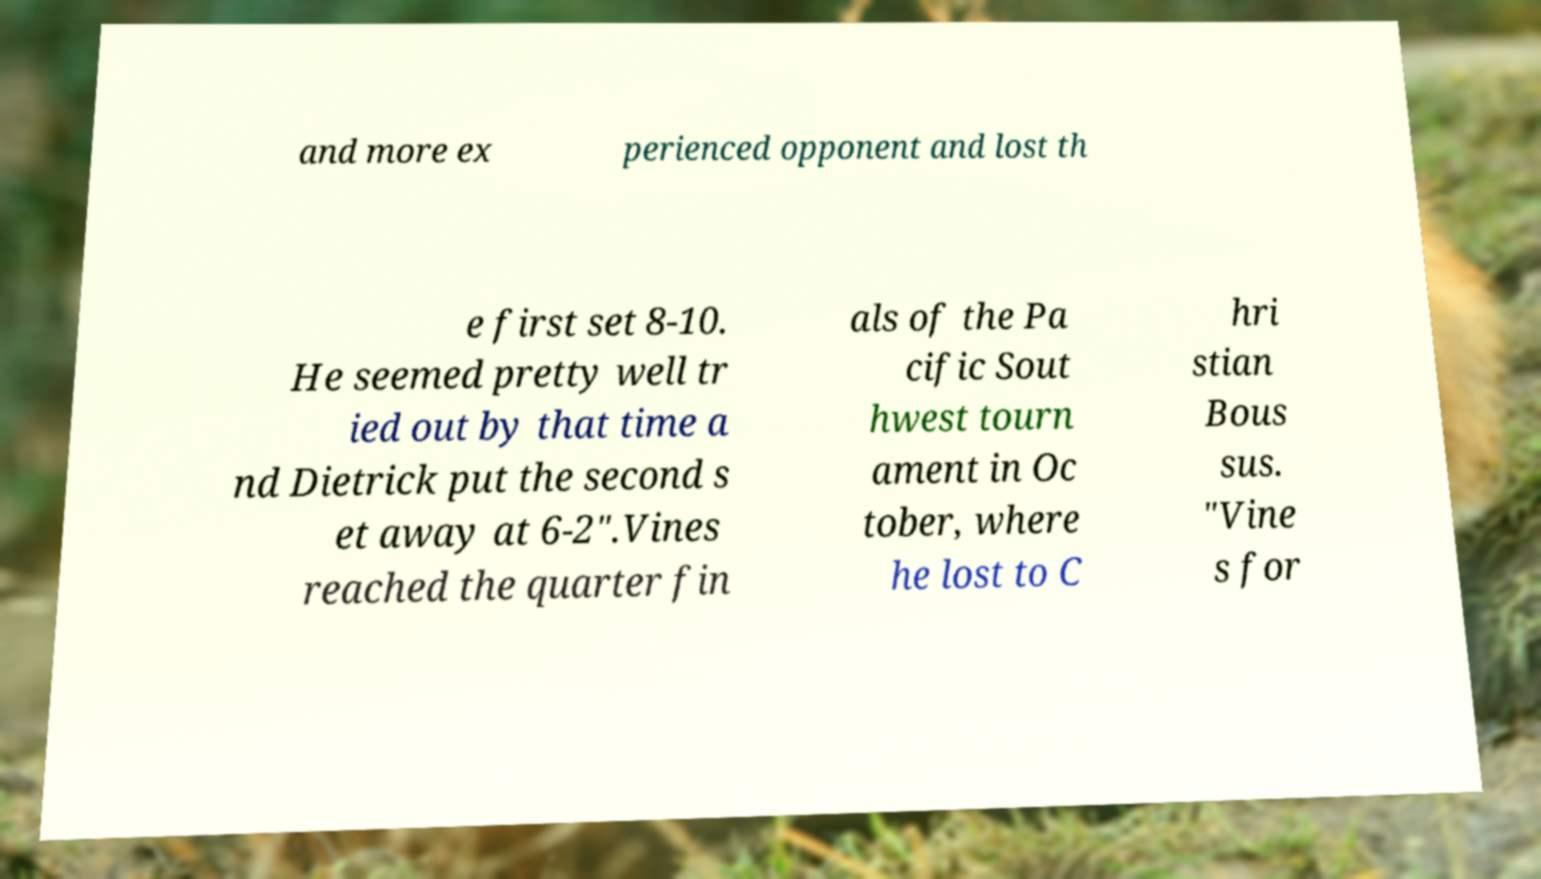Could you extract and type out the text from this image? and more ex perienced opponent and lost th e first set 8-10. He seemed pretty well tr ied out by that time a nd Dietrick put the second s et away at 6-2".Vines reached the quarter fin als of the Pa cific Sout hwest tourn ament in Oc tober, where he lost to C hri stian Bous sus. "Vine s for 